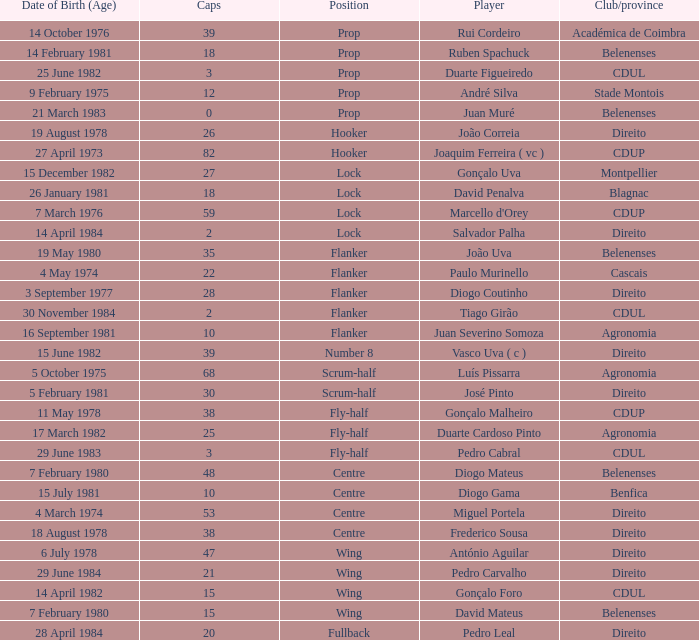How many caps have a Position of prop, and a Player of rui cordeiro? 1.0. 